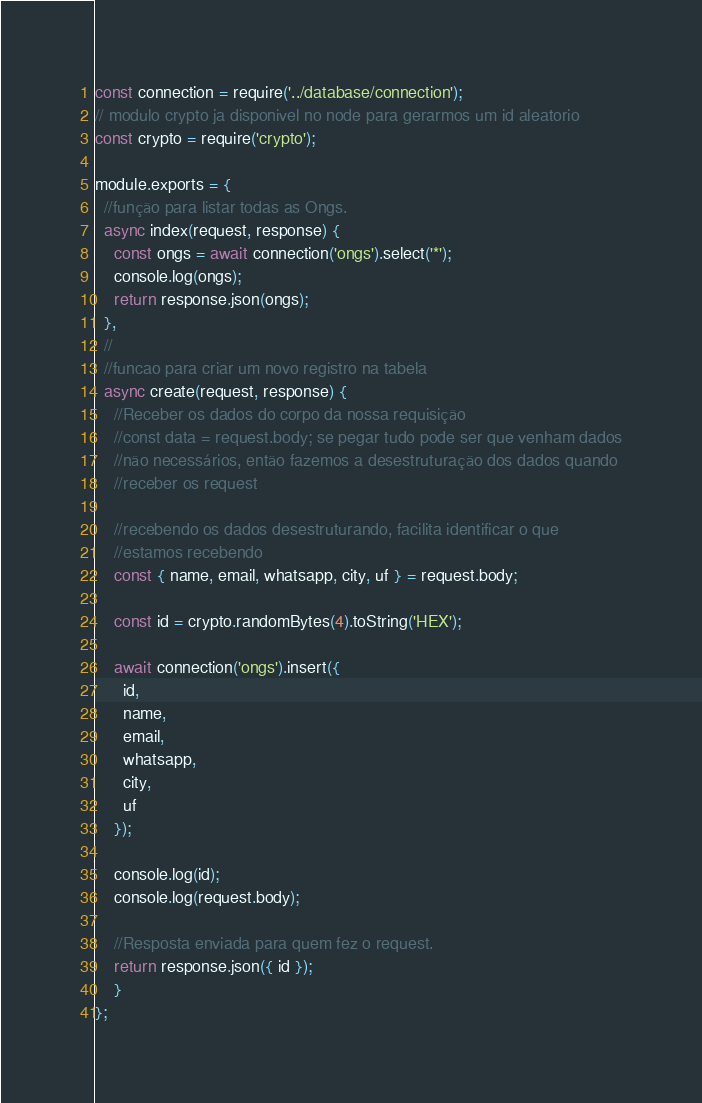<code> <loc_0><loc_0><loc_500><loc_500><_JavaScript_>const connection = require('../database/connection');
// modulo crypto ja disponivel no node para gerarmos um id aleatorio
const crypto = require('crypto');

module.exports = {
  //função para listar todas as Ongs.
  async index(request, response) {
    const ongs = await connection('ongs').select('*');
    console.log(ongs);
    return response.json(ongs);
  },
  //
  //funcao para criar um novo registro na tabela
  async create(request, response) {
    //Receber os dados do corpo da nossa requisição
    //const data = request.body; se pegar tudo pode ser que venham dados
    //não necessários, então fazemos a desestruturação dos dados quando
    //receber os request
    
    //recebendo os dados desestruturando, facilita identificar o que
    //estamos recebendo
    const { name, email, whatsapp, city, uf } = request.body;

    const id = crypto.randomBytes(4).toString('HEX');

    await connection('ongs').insert({
      id,
      name,
      email,
      whatsapp,
      city,
      uf
    });

    console.log(id);
    console.log(request.body);
    
    //Resposta enviada para quem fez o request.
    return response.json({ id });
    }
};</code> 